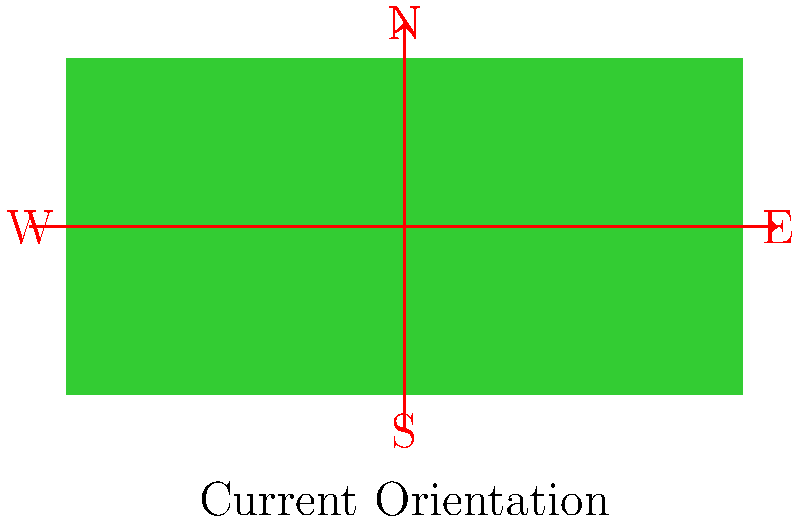As the football coach at Lakewood High School, you're working on a new play strategy and need to align the football field diagram with the actual compass directions. The current diagram shows the field oriented with the long sides running North-South. If the actual field is oriented with the long sides running East-West, how many degrees and in which direction should you rotate the diagram to match the real-world orientation? To solve this problem, let's follow these steps:

1) In the current diagram, the long sides of the field are aligned North-South.

2) In reality, the long sides of the field run East-West.

3) To transform the diagram from North-South to East-West orientation, we need to rotate it 90 degrees.

4) The direction of rotation is important. We want the North end of the field to become the West end.

5) In mathematics and geometry, the standard direction of rotation is counterclockwise (CCW). 

6) To make North become West, we need to rotate the diagram 90 degrees clockwise (CW).

7) Clockwise rotation is equivalent to a negative angle in mathematical notation.

Therefore, we need to rotate the diagram by -90 degrees (or 90 degrees clockwise).
Answer: -90° (or 90° clockwise) 